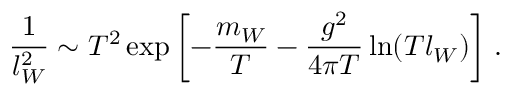Convert formula to latex. <formula><loc_0><loc_0><loc_500><loc_500>\frac { 1 } { l _ { W } ^ { 2 } } \sim T ^ { 2 } \exp \left [ - \frac { m _ { W } } T - \frac { g ^ { 2 } } { 4 \pi T } \ln ( T l _ { W } ) \right ] \, .</formula> 